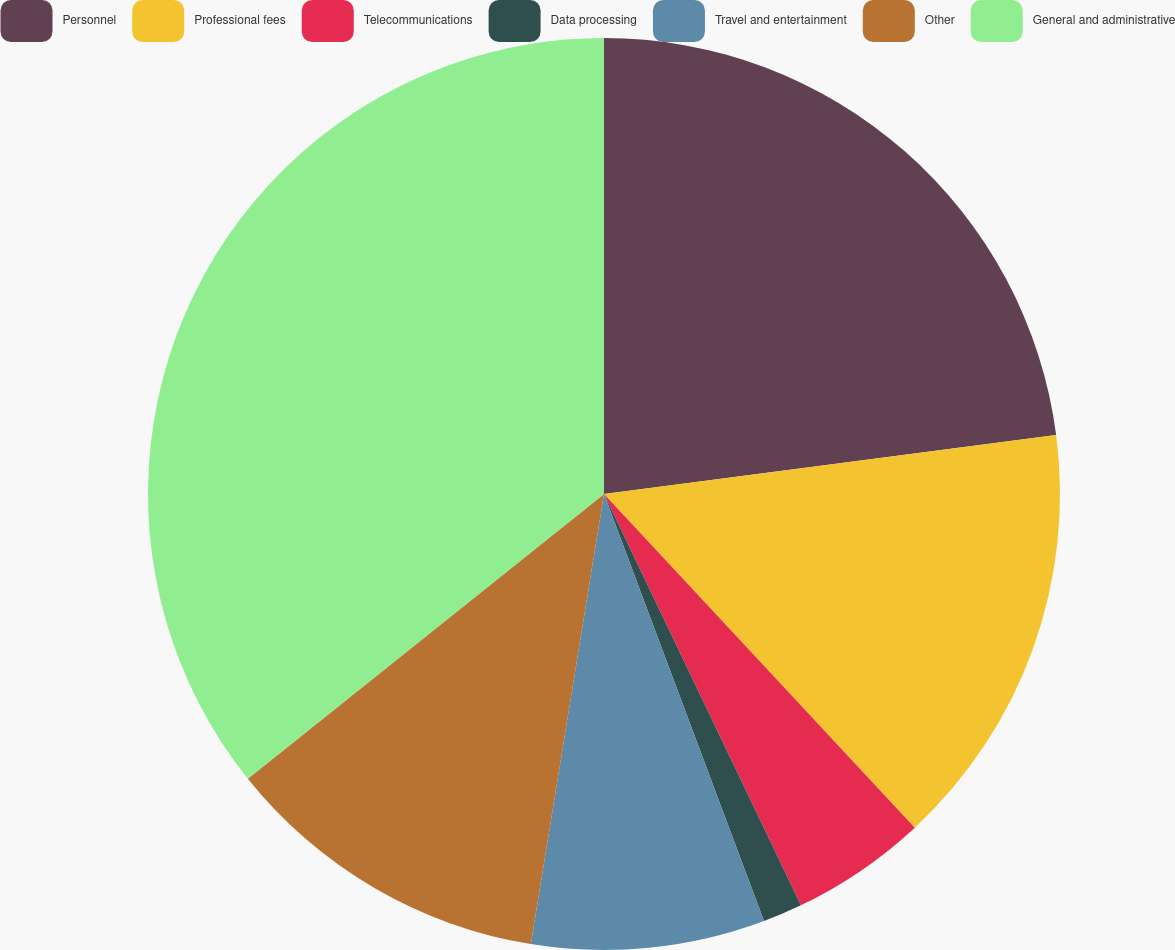<chart> <loc_0><loc_0><loc_500><loc_500><pie_chart><fcel>Personnel<fcel>Professional fees<fcel>Telecommunications<fcel>Data processing<fcel>Travel and entertainment<fcel>Other<fcel>General and administrative<nl><fcel>22.93%<fcel>15.13%<fcel>4.83%<fcel>1.4%<fcel>8.27%<fcel>11.7%<fcel>35.73%<nl></chart> 